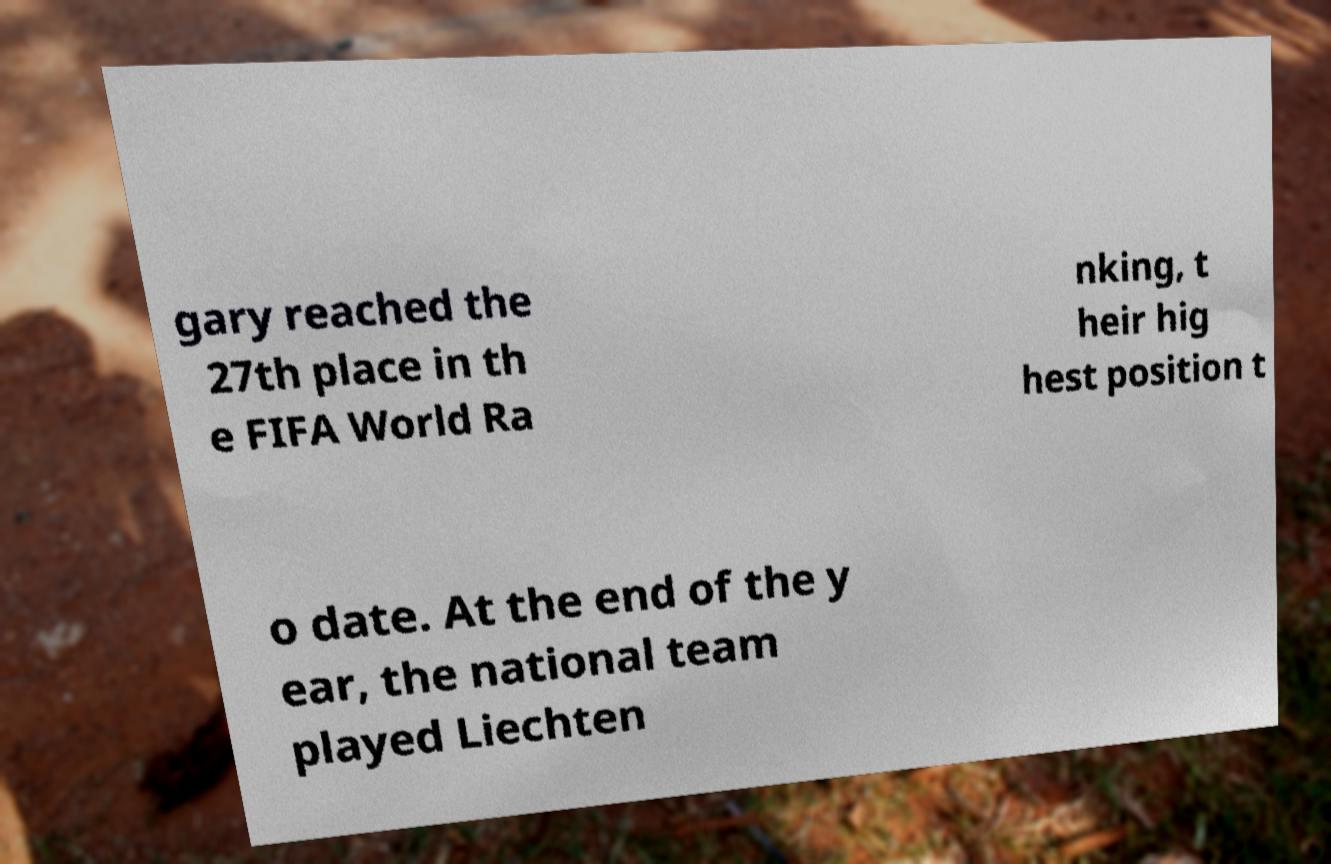Can you read and provide the text displayed in the image?This photo seems to have some interesting text. Can you extract and type it out for me? gary reached the 27th place in th e FIFA World Ra nking, t heir hig hest position t o date. At the end of the y ear, the national team played Liechten 